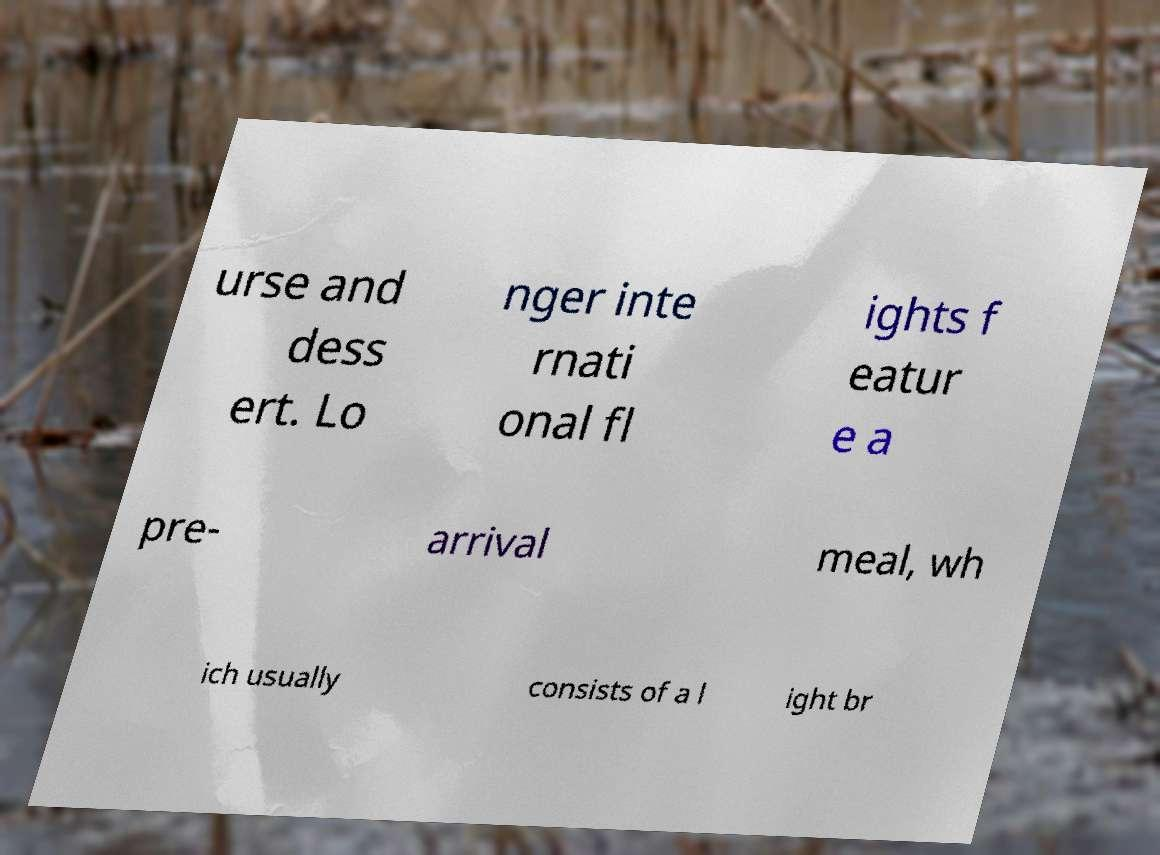Could you assist in decoding the text presented in this image and type it out clearly? urse and dess ert. Lo nger inte rnati onal fl ights f eatur e a pre- arrival meal, wh ich usually consists of a l ight br 